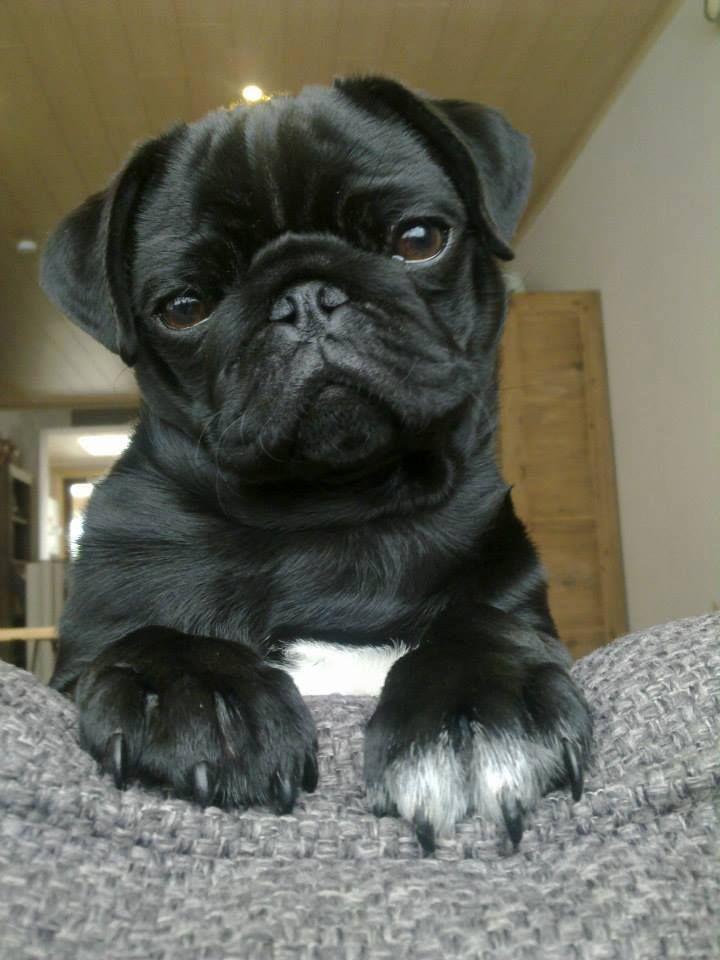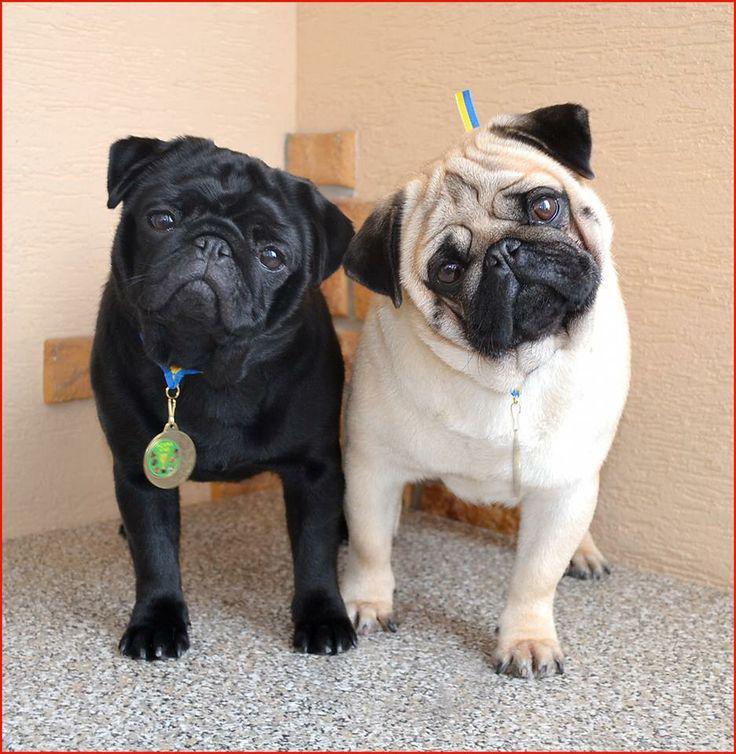The first image is the image on the left, the second image is the image on the right. Analyze the images presented: Is the assertion "The right image contains exactly two dogs." valid? Answer yes or no. Yes. The first image is the image on the left, the second image is the image on the right. Examine the images to the left and right. Is the description "The left image features one forward-facing black pug with front paws draped over something, and the right image features a black pug to the left of a beige pug." accurate? Answer yes or no. Yes. 